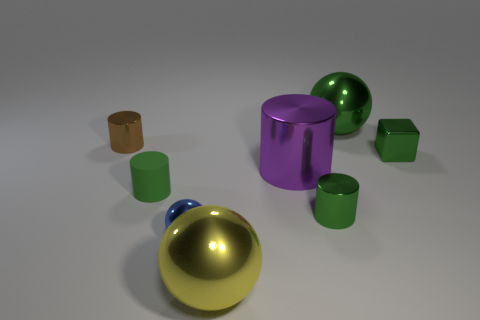Can you describe the texture of the objects? The objects exhibit smooth and reflective textures, indicative of a polished metallic or plastic finish, which is accentuated by the light source in the scene. 